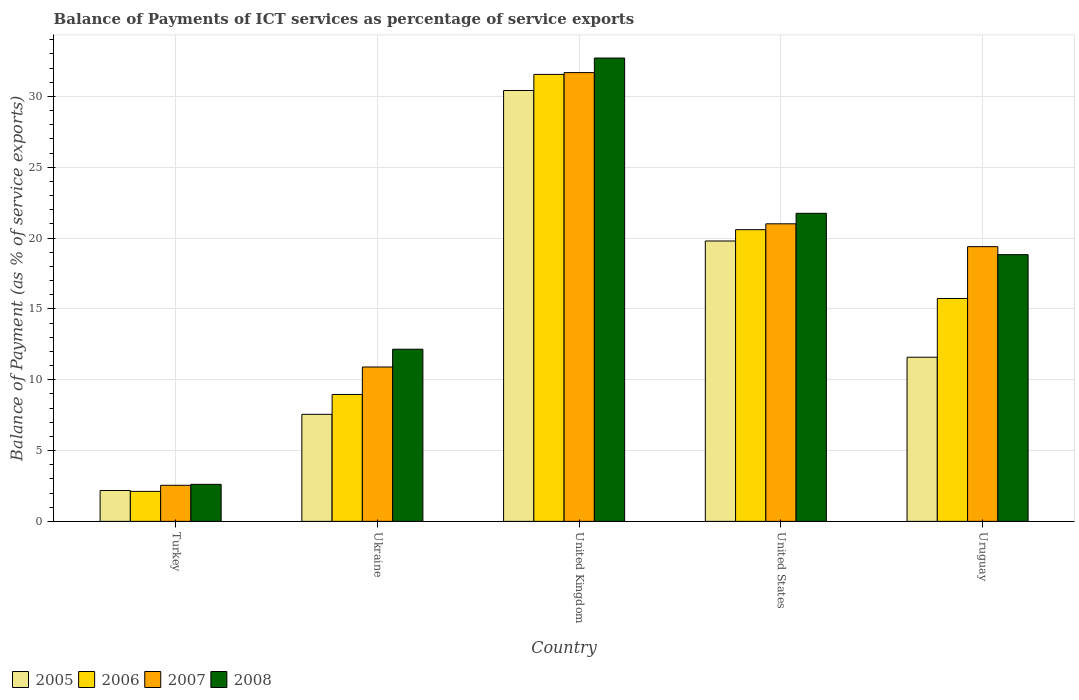How many groups of bars are there?
Offer a very short reply. 5. Are the number of bars on each tick of the X-axis equal?
Make the answer very short. Yes. How many bars are there on the 1st tick from the right?
Make the answer very short. 4. What is the balance of payments of ICT services in 2005 in Uruguay?
Offer a very short reply. 11.59. Across all countries, what is the maximum balance of payments of ICT services in 2006?
Offer a very short reply. 31.55. Across all countries, what is the minimum balance of payments of ICT services in 2007?
Your answer should be very brief. 2.55. In which country was the balance of payments of ICT services in 2005 minimum?
Offer a terse response. Turkey. What is the total balance of payments of ICT services in 2005 in the graph?
Ensure brevity in your answer.  71.52. What is the difference between the balance of payments of ICT services in 2006 in Turkey and that in Ukraine?
Keep it short and to the point. -6.84. What is the difference between the balance of payments of ICT services in 2006 in United Kingdom and the balance of payments of ICT services in 2007 in United States?
Ensure brevity in your answer.  10.55. What is the average balance of payments of ICT services in 2006 per country?
Your response must be concise. 15.79. What is the difference between the balance of payments of ICT services of/in 2006 and balance of payments of ICT services of/in 2008 in Turkey?
Offer a terse response. -0.5. What is the ratio of the balance of payments of ICT services in 2006 in United Kingdom to that in United States?
Your response must be concise. 1.53. What is the difference between the highest and the second highest balance of payments of ICT services in 2005?
Provide a succinct answer. -8.2. What is the difference between the highest and the lowest balance of payments of ICT services in 2008?
Provide a short and direct response. 30.09. Is it the case that in every country, the sum of the balance of payments of ICT services in 2007 and balance of payments of ICT services in 2008 is greater than the sum of balance of payments of ICT services in 2005 and balance of payments of ICT services in 2006?
Your answer should be compact. No. What does the 4th bar from the left in United Kingdom represents?
Provide a succinct answer. 2008. What does the 4th bar from the right in United Kingdom represents?
Offer a very short reply. 2005. Is it the case that in every country, the sum of the balance of payments of ICT services in 2007 and balance of payments of ICT services in 2006 is greater than the balance of payments of ICT services in 2008?
Give a very brief answer. Yes. How many bars are there?
Your answer should be compact. 20. Are all the bars in the graph horizontal?
Ensure brevity in your answer.  No. Does the graph contain any zero values?
Ensure brevity in your answer.  No. Does the graph contain grids?
Provide a short and direct response. Yes. How many legend labels are there?
Ensure brevity in your answer.  4. How are the legend labels stacked?
Ensure brevity in your answer.  Horizontal. What is the title of the graph?
Your response must be concise. Balance of Payments of ICT services as percentage of service exports. What is the label or title of the Y-axis?
Provide a succinct answer. Balance of Payment (as % of service exports). What is the Balance of Payment (as % of service exports) in 2005 in Turkey?
Your response must be concise. 2.18. What is the Balance of Payment (as % of service exports) of 2006 in Turkey?
Your response must be concise. 2.12. What is the Balance of Payment (as % of service exports) of 2007 in Turkey?
Make the answer very short. 2.55. What is the Balance of Payment (as % of service exports) in 2008 in Turkey?
Ensure brevity in your answer.  2.61. What is the Balance of Payment (as % of service exports) in 2005 in Ukraine?
Your response must be concise. 7.56. What is the Balance of Payment (as % of service exports) of 2006 in Ukraine?
Provide a short and direct response. 8.96. What is the Balance of Payment (as % of service exports) of 2007 in Ukraine?
Give a very brief answer. 10.9. What is the Balance of Payment (as % of service exports) of 2008 in Ukraine?
Make the answer very short. 12.15. What is the Balance of Payment (as % of service exports) of 2005 in United Kingdom?
Offer a very short reply. 30.41. What is the Balance of Payment (as % of service exports) in 2006 in United Kingdom?
Ensure brevity in your answer.  31.55. What is the Balance of Payment (as % of service exports) of 2007 in United Kingdom?
Your answer should be compact. 31.68. What is the Balance of Payment (as % of service exports) of 2008 in United Kingdom?
Ensure brevity in your answer.  32.7. What is the Balance of Payment (as % of service exports) of 2005 in United States?
Your answer should be compact. 19.79. What is the Balance of Payment (as % of service exports) in 2006 in United States?
Your answer should be very brief. 20.59. What is the Balance of Payment (as % of service exports) of 2007 in United States?
Ensure brevity in your answer.  21. What is the Balance of Payment (as % of service exports) in 2008 in United States?
Provide a succinct answer. 21.74. What is the Balance of Payment (as % of service exports) in 2005 in Uruguay?
Make the answer very short. 11.59. What is the Balance of Payment (as % of service exports) of 2006 in Uruguay?
Keep it short and to the point. 15.73. What is the Balance of Payment (as % of service exports) in 2007 in Uruguay?
Your response must be concise. 19.39. What is the Balance of Payment (as % of service exports) in 2008 in Uruguay?
Offer a terse response. 18.83. Across all countries, what is the maximum Balance of Payment (as % of service exports) of 2005?
Keep it short and to the point. 30.41. Across all countries, what is the maximum Balance of Payment (as % of service exports) of 2006?
Ensure brevity in your answer.  31.55. Across all countries, what is the maximum Balance of Payment (as % of service exports) in 2007?
Ensure brevity in your answer.  31.68. Across all countries, what is the maximum Balance of Payment (as % of service exports) of 2008?
Your response must be concise. 32.7. Across all countries, what is the minimum Balance of Payment (as % of service exports) in 2005?
Your answer should be compact. 2.18. Across all countries, what is the minimum Balance of Payment (as % of service exports) in 2006?
Offer a very short reply. 2.12. Across all countries, what is the minimum Balance of Payment (as % of service exports) in 2007?
Provide a short and direct response. 2.55. Across all countries, what is the minimum Balance of Payment (as % of service exports) in 2008?
Offer a terse response. 2.61. What is the total Balance of Payment (as % of service exports) of 2005 in the graph?
Provide a succinct answer. 71.52. What is the total Balance of Payment (as % of service exports) of 2006 in the graph?
Your answer should be very brief. 78.94. What is the total Balance of Payment (as % of service exports) in 2007 in the graph?
Your response must be concise. 85.51. What is the total Balance of Payment (as % of service exports) of 2008 in the graph?
Make the answer very short. 88.04. What is the difference between the Balance of Payment (as % of service exports) of 2005 in Turkey and that in Ukraine?
Make the answer very short. -5.38. What is the difference between the Balance of Payment (as % of service exports) of 2006 in Turkey and that in Ukraine?
Provide a short and direct response. -6.84. What is the difference between the Balance of Payment (as % of service exports) of 2007 in Turkey and that in Ukraine?
Your answer should be compact. -8.35. What is the difference between the Balance of Payment (as % of service exports) of 2008 in Turkey and that in Ukraine?
Give a very brief answer. -9.54. What is the difference between the Balance of Payment (as % of service exports) in 2005 in Turkey and that in United Kingdom?
Ensure brevity in your answer.  -28.23. What is the difference between the Balance of Payment (as % of service exports) in 2006 in Turkey and that in United Kingdom?
Give a very brief answer. -29.43. What is the difference between the Balance of Payment (as % of service exports) in 2007 in Turkey and that in United Kingdom?
Give a very brief answer. -29.13. What is the difference between the Balance of Payment (as % of service exports) in 2008 in Turkey and that in United Kingdom?
Provide a short and direct response. -30.09. What is the difference between the Balance of Payment (as % of service exports) of 2005 in Turkey and that in United States?
Your answer should be very brief. -17.61. What is the difference between the Balance of Payment (as % of service exports) in 2006 in Turkey and that in United States?
Your answer should be compact. -18.47. What is the difference between the Balance of Payment (as % of service exports) of 2007 in Turkey and that in United States?
Keep it short and to the point. -18.46. What is the difference between the Balance of Payment (as % of service exports) of 2008 in Turkey and that in United States?
Make the answer very short. -19.13. What is the difference between the Balance of Payment (as % of service exports) of 2005 in Turkey and that in Uruguay?
Offer a terse response. -9.41. What is the difference between the Balance of Payment (as % of service exports) of 2006 in Turkey and that in Uruguay?
Provide a short and direct response. -13.62. What is the difference between the Balance of Payment (as % of service exports) in 2007 in Turkey and that in Uruguay?
Your response must be concise. -16.84. What is the difference between the Balance of Payment (as % of service exports) in 2008 in Turkey and that in Uruguay?
Provide a succinct answer. -16.21. What is the difference between the Balance of Payment (as % of service exports) of 2005 in Ukraine and that in United Kingdom?
Your answer should be very brief. -22.86. What is the difference between the Balance of Payment (as % of service exports) in 2006 in Ukraine and that in United Kingdom?
Provide a short and direct response. -22.59. What is the difference between the Balance of Payment (as % of service exports) in 2007 in Ukraine and that in United Kingdom?
Make the answer very short. -20.78. What is the difference between the Balance of Payment (as % of service exports) in 2008 in Ukraine and that in United Kingdom?
Make the answer very short. -20.55. What is the difference between the Balance of Payment (as % of service exports) in 2005 in Ukraine and that in United States?
Give a very brief answer. -12.23. What is the difference between the Balance of Payment (as % of service exports) in 2006 in Ukraine and that in United States?
Provide a short and direct response. -11.63. What is the difference between the Balance of Payment (as % of service exports) of 2007 in Ukraine and that in United States?
Keep it short and to the point. -10.11. What is the difference between the Balance of Payment (as % of service exports) in 2008 in Ukraine and that in United States?
Keep it short and to the point. -9.59. What is the difference between the Balance of Payment (as % of service exports) in 2005 in Ukraine and that in Uruguay?
Ensure brevity in your answer.  -4.03. What is the difference between the Balance of Payment (as % of service exports) of 2006 in Ukraine and that in Uruguay?
Your answer should be compact. -6.77. What is the difference between the Balance of Payment (as % of service exports) in 2007 in Ukraine and that in Uruguay?
Your answer should be compact. -8.49. What is the difference between the Balance of Payment (as % of service exports) in 2008 in Ukraine and that in Uruguay?
Offer a very short reply. -6.68. What is the difference between the Balance of Payment (as % of service exports) of 2005 in United Kingdom and that in United States?
Offer a very short reply. 10.62. What is the difference between the Balance of Payment (as % of service exports) of 2006 in United Kingdom and that in United States?
Offer a terse response. 10.96. What is the difference between the Balance of Payment (as % of service exports) in 2007 in United Kingdom and that in United States?
Your response must be concise. 10.67. What is the difference between the Balance of Payment (as % of service exports) in 2008 in United Kingdom and that in United States?
Keep it short and to the point. 10.96. What is the difference between the Balance of Payment (as % of service exports) in 2005 in United Kingdom and that in Uruguay?
Your answer should be very brief. 18.83. What is the difference between the Balance of Payment (as % of service exports) of 2006 in United Kingdom and that in Uruguay?
Ensure brevity in your answer.  15.82. What is the difference between the Balance of Payment (as % of service exports) in 2007 in United Kingdom and that in Uruguay?
Offer a very short reply. 12.29. What is the difference between the Balance of Payment (as % of service exports) of 2008 in United Kingdom and that in Uruguay?
Your answer should be very brief. 13.88. What is the difference between the Balance of Payment (as % of service exports) of 2005 in United States and that in Uruguay?
Make the answer very short. 8.2. What is the difference between the Balance of Payment (as % of service exports) in 2006 in United States and that in Uruguay?
Your answer should be very brief. 4.86. What is the difference between the Balance of Payment (as % of service exports) in 2007 in United States and that in Uruguay?
Give a very brief answer. 1.61. What is the difference between the Balance of Payment (as % of service exports) of 2008 in United States and that in Uruguay?
Your answer should be compact. 2.92. What is the difference between the Balance of Payment (as % of service exports) in 2005 in Turkey and the Balance of Payment (as % of service exports) in 2006 in Ukraine?
Make the answer very short. -6.78. What is the difference between the Balance of Payment (as % of service exports) of 2005 in Turkey and the Balance of Payment (as % of service exports) of 2007 in Ukraine?
Provide a succinct answer. -8.72. What is the difference between the Balance of Payment (as % of service exports) in 2005 in Turkey and the Balance of Payment (as % of service exports) in 2008 in Ukraine?
Offer a terse response. -9.97. What is the difference between the Balance of Payment (as % of service exports) in 2006 in Turkey and the Balance of Payment (as % of service exports) in 2007 in Ukraine?
Ensure brevity in your answer.  -8.78. What is the difference between the Balance of Payment (as % of service exports) of 2006 in Turkey and the Balance of Payment (as % of service exports) of 2008 in Ukraine?
Offer a very short reply. -10.03. What is the difference between the Balance of Payment (as % of service exports) of 2007 in Turkey and the Balance of Payment (as % of service exports) of 2008 in Ukraine?
Offer a very short reply. -9.6. What is the difference between the Balance of Payment (as % of service exports) of 2005 in Turkey and the Balance of Payment (as % of service exports) of 2006 in United Kingdom?
Your answer should be very brief. -29.37. What is the difference between the Balance of Payment (as % of service exports) in 2005 in Turkey and the Balance of Payment (as % of service exports) in 2007 in United Kingdom?
Provide a succinct answer. -29.5. What is the difference between the Balance of Payment (as % of service exports) in 2005 in Turkey and the Balance of Payment (as % of service exports) in 2008 in United Kingdom?
Give a very brief answer. -30.52. What is the difference between the Balance of Payment (as % of service exports) in 2006 in Turkey and the Balance of Payment (as % of service exports) in 2007 in United Kingdom?
Ensure brevity in your answer.  -29.56. What is the difference between the Balance of Payment (as % of service exports) in 2006 in Turkey and the Balance of Payment (as % of service exports) in 2008 in United Kingdom?
Your answer should be compact. -30.59. What is the difference between the Balance of Payment (as % of service exports) in 2007 in Turkey and the Balance of Payment (as % of service exports) in 2008 in United Kingdom?
Your answer should be compact. -30.16. What is the difference between the Balance of Payment (as % of service exports) of 2005 in Turkey and the Balance of Payment (as % of service exports) of 2006 in United States?
Give a very brief answer. -18.41. What is the difference between the Balance of Payment (as % of service exports) of 2005 in Turkey and the Balance of Payment (as % of service exports) of 2007 in United States?
Offer a terse response. -18.82. What is the difference between the Balance of Payment (as % of service exports) of 2005 in Turkey and the Balance of Payment (as % of service exports) of 2008 in United States?
Keep it short and to the point. -19.57. What is the difference between the Balance of Payment (as % of service exports) in 2006 in Turkey and the Balance of Payment (as % of service exports) in 2007 in United States?
Make the answer very short. -18.89. What is the difference between the Balance of Payment (as % of service exports) of 2006 in Turkey and the Balance of Payment (as % of service exports) of 2008 in United States?
Offer a very short reply. -19.63. What is the difference between the Balance of Payment (as % of service exports) in 2007 in Turkey and the Balance of Payment (as % of service exports) in 2008 in United States?
Keep it short and to the point. -19.2. What is the difference between the Balance of Payment (as % of service exports) of 2005 in Turkey and the Balance of Payment (as % of service exports) of 2006 in Uruguay?
Your response must be concise. -13.55. What is the difference between the Balance of Payment (as % of service exports) in 2005 in Turkey and the Balance of Payment (as % of service exports) in 2007 in Uruguay?
Offer a terse response. -17.21. What is the difference between the Balance of Payment (as % of service exports) of 2005 in Turkey and the Balance of Payment (as % of service exports) of 2008 in Uruguay?
Provide a short and direct response. -16.65. What is the difference between the Balance of Payment (as % of service exports) of 2006 in Turkey and the Balance of Payment (as % of service exports) of 2007 in Uruguay?
Ensure brevity in your answer.  -17.27. What is the difference between the Balance of Payment (as % of service exports) in 2006 in Turkey and the Balance of Payment (as % of service exports) in 2008 in Uruguay?
Ensure brevity in your answer.  -16.71. What is the difference between the Balance of Payment (as % of service exports) of 2007 in Turkey and the Balance of Payment (as % of service exports) of 2008 in Uruguay?
Your answer should be very brief. -16.28. What is the difference between the Balance of Payment (as % of service exports) in 2005 in Ukraine and the Balance of Payment (as % of service exports) in 2006 in United Kingdom?
Your response must be concise. -23.99. What is the difference between the Balance of Payment (as % of service exports) of 2005 in Ukraine and the Balance of Payment (as % of service exports) of 2007 in United Kingdom?
Give a very brief answer. -24.12. What is the difference between the Balance of Payment (as % of service exports) of 2005 in Ukraine and the Balance of Payment (as % of service exports) of 2008 in United Kingdom?
Your response must be concise. -25.15. What is the difference between the Balance of Payment (as % of service exports) in 2006 in Ukraine and the Balance of Payment (as % of service exports) in 2007 in United Kingdom?
Provide a short and direct response. -22.72. What is the difference between the Balance of Payment (as % of service exports) in 2006 in Ukraine and the Balance of Payment (as % of service exports) in 2008 in United Kingdom?
Provide a short and direct response. -23.75. What is the difference between the Balance of Payment (as % of service exports) of 2007 in Ukraine and the Balance of Payment (as % of service exports) of 2008 in United Kingdom?
Your answer should be compact. -21.81. What is the difference between the Balance of Payment (as % of service exports) of 2005 in Ukraine and the Balance of Payment (as % of service exports) of 2006 in United States?
Your answer should be compact. -13.03. What is the difference between the Balance of Payment (as % of service exports) in 2005 in Ukraine and the Balance of Payment (as % of service exports) in 2007 in United States?
Your answer should be compact. -13.45. What is the difference between the Balance of Payment (as % of service exports) of 2005 in Ukraine and the Balance of Payment (as % of service exports) of 2008 in United States?
Your response must be concise. -14.19. What is the difference between the Balance of Payment (as % of service exports) of 2006 in Ukraine and the Balance of Payment (as % of service exports) of 2007 in United States?
Your answer should be compact. -12.05. What is the difference between the Balance of Payment (as % of service exports) in 2006 in Ukraine and the Balance of Payment (as % of service exports) in 2008 in United States?
Your answer should be compact. -12.79. What is the difference between the Balance of Payment (as % of service exports) in 2007 in Ukraine and the Balance of Payment (as % of service exports) in 2008 in United States?
Provide a succinct answer. -10.85. What is the difference between the Balance of Payment (as % of service exports) in 2005 in Ukraine and the Balance of Payment (as % of service exports) in 2006 in Uruguay?
Give a very brief answer. -8.18. What is the difference between the Balance of Payment (as % of service exports) in 2005 in Ukraine and the Balance of Payment (as % of service exports) in 2007 in Uruguay?
Ensure brevity in your answer.  -11.83. What is the difference between the Balance of Payment (as % of service exports) in 2005 in Ukraine and the Balance of Payment (as % of service exports) in 2008 in Uruguay?
Provide a short and direct response. -11.27. What is the difference between the Balance of Payment (as % of service exports) of 2006 in Ukraine and the Balance of Payment (as % of service exports) of 2007 in Uruguay?
Offer a terse response. -10.43. What is the difference between the Balance of Payment (as % of service exports) of 2006 in Ukraine and the Balance of Payment (as % of service exports) of 2008 in Uruguay?
Make the answer very short. -9.87. What is the difference between the Balance of Payment (as % of service exports) in 2007 in Ukraine and the Balance of Payment (as % of service exports) in 2008 in Uruguay?
Your answer should be very brief. -7.93. What is the difference between the Balance of Payment (as % of service exports) of 2005 in United Kingdom and the Balance of Payment (as % of service exports) of 2006 in United States?
Provide a short and direct response. 9.82. What is the difference between the Balance of Payment (as % of service exports) in 2005 in United Kingdom and the Balance of Payment (as % of service exports) in 2007 in United States?
Your answer should be very brief. 9.41. What is the difference between the Balance of Payment (as % of service exports) in 2005 in United Kingdom and the Balance of Payment (as % of service exports) in 2008 in United States?
Your answer should be very brief. 8.67. What is the difference between the Balance of Payment (as % of service exports) in 2006 in United Kingdom and the Balance of Payment (as % of service exports) in 2007 in United States?
Give a very brief answer. 10.55. What is the difference between the Balance of Payment (as % of service exports) in 2006 in United Kingdom and the Balance of Payment (as % of service exports) in 2008 in United States?
Your answer should be compact. 9.8. What is the difference between the Balance of Payment (as % of service exports) of 2007 in United Kingdom and the Balance of Payment (as % of service exports) of 2008 in United States?
Offer a very short reply. 9.93. What is the difference between the Balance of Payment (as % of service exports) in 2005 in United Kingdom and the Balance of Payment (as % of service exports) in 2006 in Uruguay?
Make the answer very short. 14.68. What is the difference between the Balance of Payment (as % of service exports) of 2005 in United Kingdom and the Balance of Payment (as % of service exports) of 2007 in Uruguay?
Ensure brevity in your answer.  11.02. What is the difference between the Balance of Payment (as % of service exports) of 2005 in United Kingdom and the Balance of Payment (as % of service exports) of 2008 in Uruguay?
Your answer should be very brief. 11.59. What is the difference between the Balance of Payment (as % of service exports) in 2006 in United Kingdom and the Balance of Payment (as % of service exports) in 2007 in Uruguay?
Your response must be concise. 12.16. What is the difference between the Balance of Payment (as % of service exports) in 2006 in United Kingdom and the Balance of Payment (as % of service exports) in 2008 in Uruguay?
Provide a succinct answer. 12.72. What is the difference between the Balance of Payment (as % of service exports) in 2007 in United Kingdom and the Balance of Payment (as % of service exports) in 2008 in Uruguay?
Give a very brief answer. 12.85. What is the difference between the Balance of Payment (as % of service exports) in 2005 in United States and the Balance of Payment (as % of service exports) in 2006 in Uruguay?
Make the answer very short. 4.06. What is the difference between the Balance of Payment (as % of service exports) of 2005 in United States and the Balance of Payment (as % of service exports) of 2007 in Uruguay?
Your answer should be very brief. 0.4. What is the difference between the Balance of Payment (as % of service exports) in 2005 in United States and the Balance of Payment (as % of service exports) in 2008 in Uruguay?
Offer a terse response. 0.96. What is the difference between the Balance of Payment (as % of service exports) in 2006 in United States and the Balance of Payment (as % of service exports) in 2007 in Uruguay?
Give a very brief answer. 1.2. What is the difference between the Balance of Payment (as % of service exports) in 2006 in United States and the Balance of Payment (as % of service exports) in 2008 in Uruguay?
Ensure brevity in your answer.  1.76. What is the difference between the Balance of Payment (as % of service exports) in 2007 in United States and the Balance of Payment (as % of service exports) in 2008 in Uruguay?
Make the answer very short. 2.18. What is the average Balance of Payment (as % of service exports) of 2005 per country?
Give a very brief answer. 14.3. What is the average Balance of Payment (as % of service exports) in 2006 per country?
Your answer should be compact. 15.79. What is the average Balance of Payment (as % of service exports) of 2007 per country?
Keep it short and to the point. 17.1. What is the average Balance of Payment (as % of service exports) in 2008 per country?
Offer a terse response. 17.61. What is the difference between the Balance of Payment (as % of service exports) in 2005 and Balance of Payment (as % of service exports) in 2006 in Turkey?
Your response must be concise. 0.06. What is the difference between the Balance of Payment (as % of service exports) in 2005 and Balance of Payment (as % of service exports) in 2007 in Turkey?
Your answer should be compact. -0.37. What is the difference between the Balance of Payment (as % of service exports) of 2005 and Balance of Payment (as % of service exports) of 2008 in Turkey?
Give a very brief answer. -0.44. What is the difference between the Balance of Payment (as % of service exports) of 2006 and Balance of Payment (as % of service exports) of 2007 in Turkey?
Offer a terse response. -0.43. What is the difference between the Balance of Payment (as % of service exports) of 2006 and Balance of Payment (as % of service exports) of 2008 in Turkey?
Provide a succinct answer. -0.5. What is the difference between the Balance of Payment (as % of service exports) in 2007 and Balance of Payment (as % of service exports) in 2008 in Turkey?
Provide a short and direct response. -0.07. What is the difference between the Balance of Payment (as % of service exports) of 2005 and Balance of Payment (as % of service exports) of 2006 in Ukraine?
Keep it short and to the point. -1.4. What is the difference between the Balance of Payment (as % of service exports) of 2005 and Balance of Payment (as % of service exports) of 2007 in Ukraine?
Ensure brevity in your answer.  -3.34. What is the difference between the Balance of Payment (as % of service exports) in 2005 and Balance of Payment (as % of service exports) in 2008 in Ukraine?
Your answer should be compact. -4.59. What is the difference between the Balance of Payment (as % of service exports) in 2006 and Balance of Payment (as % of service exports) in 2007 in Ukraine?
Make the answer very short. -1.94. What is the difference between the Balance of Payment (as % of service exports) in 2006 and Balance of Payment (as % of service exports) in 2008 in Ukraine?
Your answer should be compact. -3.19. What is the difference between the Balance of Payment (as % of service exports) of 2007 and Balance of Payment (as % of service exports) of 2008 in Ukraine?
Ensure brevity in your answer.  -1.25. What is the difference between the Balance of Payment (as % of service exports) in 2005 and Balance of Payment (as % of service exports) in 2006 in United Kingdom?
Provide a succinct answer. -1.14. What is the difference between the Balance of Payment (as % of service exports) of 2005 and Balance of Payment (as % of service exports) of 2007 in United Kingdom?
Make the answer very short. -1.26. What is the difference between the Balance of Payment (as % of service exports) of 2005 and Balance of Payment (as % of service exports) of 2008 in United Kingdom?
Your answer should be very brief. -2.29. What is the difference between the Balance of Payment (as % of service exports) in 2006 and Balance of Payment (as % of service exports) in 2007 in United Kingdom?
Ensure brevity in your answer.  -0.13. What is the difference between the Balance of Payment (as % of service exports) in 2006 and Balance of Payment (as % of service exports) in 2008 in United Kingdom?
Offer a terse response. -1.16. What is the difference between the Balance of Payment (as % of service exports) in 2007 and Balance of Payment (as % of service exports) in 2008 in United Kingdom?
Ensure brevity in your answer.  -1.03. What is the difference between the Balance of Payment (as % of service exports) in 2005 and Balance of Payment (as % of service exports) in 2006 in United States?
Provide a short and direct response. -0.8. What is the difference between the Balance of Payment (as % of service exports) of 2005 and Balance of Payment (as % of service exports) of 2007 in United States?
Your response must be concise. -1.21. What is the difference between the Balance of Payment (as % of service exports) of 2005 and Balance of Payment (as % of service exports) of 2008 in United States?
Offer a very short reply. -1.95. What is the difference between the Balance of Payment (as % of service exports) of 2006 and Balance of Payment (as % of service exports) of 2007 in United States?
Provide a succinct answer. -0.41. What is the difference between the Balance of Payment (as % of service exports) of 2006 and Balance of Payment (as % of service exports) of 2008 in United States?
Your answer should be very brief. -1.15. What is the difference between the Balance of Payment (as % of service exports) of 2007 and Balance of Payment (as % of service exports) of 2008 in United States?
Your answer should be very brief. -0.74. What is the difference between the Balance of Payment (as % of service exports) in 2005 and Balance of Payment (as % of service exports) in 2006 in Uruguay?
Your answer should be very brief. -4.15. What is the difference between the Balance of Payment (as % of service exports) in 2005 and Balance of Payment (as % of service exports) in 2007 in Uruguay?
Your answer should be compact. -7.8. What is the difference between the Balance of Payment (as % of service exports) of 2005 and Balance of Payment (as % of service exports) of 2008 in Uruguay?
Your answer should be very brief. -7.24. What is the difference between the Balance of Payment (as % of service exports) in 2006 and Balance of Payment (as % of service exports) in 2007 in Uruguay?
Give a very brief answer. -3.66. What is the difference between the Balance of Payment (as % of service exports) in 2006 and Balance of Payment (as % of service exports) in 2008 in Uruguay?
Your response must be concise. -3.09. What is the difference between the Balance of Payment (as % of service exports) in 2007 and Balance of Payment (as % of service exports) in 2008 in Uruguay?
Offer a terse response. 0.56. What is the ratio of the Balance of Payment (as % of service exports) in 2005 in Turkey to that in Ukraine?
Your answer should be compact. 0.29. What is the ratio of the Balance of Payment (as % of service exports) in 2006 in Turkey to that in Ukraine?
Offer a very short reply. 0.24. What is the ratio of the Balance of Payment (as % of service exports) in 2007 in Turkey to that in Ukraine?
Provide a short and direct response. 0.23. What is the ratio of the Balance of Payment (as % of service exports) of 2008 in Turkey to that in Ukraine?
Ensure brevity in your answer.  0.22. What is the ratio of the Balance of Payment (as % of service exports) of 2005 in Turkey to that in United Kingdom?
Offer a very short reply. 0.07. What is the ratio of the Balance of Payment (as % of service exports) in 2006 in Turkey to that in United Kingdom?
Offer a very short reply. 0.07. What is the ratio of the Balance of Payment (as % of service exports) of 2007 in Turkey to that in United Kingdom?
Give a very brief answer. 0.08. What is the ratio of the Balance of Payment (as % of service exports) in 2008 in Turkey to that in United Kingdom?
Keep it short and to the point. 0.08. What is the ratio of the Balance of Payment (as % of service exports) in 2005 in Turkey to that in United States?
Provide a short and direct response. 0.11. What is the ratio of the Balance of Payment (as % of service exports) of 2006 in Turkey to that in United States?
Your answer should be compact. 0.1. What is the ratio of the Balance of Payment (as % of service exports) of 2007 in Turkey to that in United States?
Make the answer very short. 0.12. What is the ratio of the Balance of Payment (as % of service exports) of 2008 in Turkey to that in United States?
Your answer should be very brief. 0.12. What is the ratio of the Balance of Payment (as % of service exports) of 2005 in Turkey to that in Uruguay?
Make the answer very short. 0.19. What is the ratio of the Balance of Payment (as % of service exports) of 2006 in Turkey to that in Uruguay?
Ensure brevity in your answer.  0.13. What is the ratio of the Balance of Payment (as % of service exports) in 2007 in Turkey to that in Uruguay?
Your response must be concise. 0.13. What is the ratio of the Balance of Payment (as % of service exports) in 2008 in Turkey to that in Uruguay?
Give a very brief answer. 0.14. What is the ratio of the Balance of Payment (as % of service exports) in 2005 in Ukraine to that in United Kingdom?
Provide a short and direct response. 0.25. What is the ratio of the Balance of Payment (as % of service exports) in 2006 in Ukraine to that in United Kingdom?
Make the answer very short. 0.28. What is the ratio of the Balance of Payment (as % of service exports) in 2007 in Ukraine to that in United Kingdom?
Your response must be concise. 0.34. What is the ratio of the Balance of Payment (as % of service exports) of 2008 in Ukraine to that in United Kingdom?
Your answer should be compact. 0.37. What is the ratio of the Balance of Payment (as % of service exports) of 2005 in Ukraine to that in United States?
Ensure brevity in your answer.  0.38. What is the ratio of the Balance of Payment (as % of service exports) of 2006 in Ukraine to that in United States?
Your answer should be compact. 0.43. What is the ratio of the Balance of Payment (as % of service exports) in 2007 in Ukraine to that in United States?
Offer a very short reply. 0.52. What is the ratio of the Balance of Payment (as % of service exports) in 2008 in Ukraine to that in United States?
Make the answer very short. 0.56. What is the ratio of the Balance of Payment (as % of service exports) in 2005 in Ukraine to that in Uruguay?
Offer a very short reply. 0.65. What is the ratio of the Balance of Payment (as % of service exports) in 2006 in Ukraine to that in Uruguay?
Offer a terse response. 0.57. What is the ratio of the Balance of Payment (as % of service exports) of 2007 in Ukraine to that in Uruguay?
Your response must be concise. 0.56. What is the ratio of the Balance of Payment (as % of service exports) in 2008 in Ukraine to that in Uruguay?
Your response must be concise. 0.65. What is the ratio of the Balance of Payment (as % of service exports) of 2005 in United Kingdom to that in United States?
Provide a succinct answer. 1.54. What is the ratio of the Balance of Payment (as % of service exports) in 2006 in United Kingdom to that in United States?
Give a very brief answer. 1.53. What is the ratio of the Balance of Payment (as % of service exports) of 2007 in United Kingdom to that in United States?
Provide a succinct answer. 1.51. What is the ratio of the Balance of Payment (as % of service exports) in 2008 in United Kingdom to that in United States?
Keep it short and to the point. 1.5. What is the ratio of the Balance of Payment (as % of service exports) of 2005 in United Kingdom to that in Uruguay?
Provide a succinct answer. 2.62. What is the ratio of the Balance of Payment (as % of service exports) in 2006 in United Kingdom to that in Uruguay?
Provide a short and direct response. 2.01. What is the ratio of the Balance of Payment (as % of service exports) in 2007 in United Kingdom to that in Uruguay?
Ensure brevity in your answer.  1.63. What is the ratio of the Balance of Payment (as % of service exports) in 2008 in United Kingdom to that in Uruguay?
Offer a very short reply. 1.74. What is the ratio of the Balance of Payment (as % of service exports) of 2005 in United States to that in Uruguay?
Ensure brevity in your answer.  1.71. What is the ratio of the Balance of Payment (as % of service exports) in 2006 in United States to that in Uruguay?
Ensure brevity in your answer.  1.31. What is the ratio of the Balance of Payment (as % of service exports) of 2007 in United States to that in Uruguay?
Keep it short and to the point. 1.08. What is the ratio of the Balance of Payment (as % of service exports) in 2008 in United States to that in Uruguay?
Your response must be concise. 1.16. What is the difference between the highest and the second highest Balance of Payment (as % of service exports) in 2005?
Your response must be concise. 10.62. What is the difference between the highest and the second highest Balance of Payment (as % of service exports) in 2006?
Your answer should be very brief. 10.96. What is the difference between the highest and the second highest Balance of Payment (as % of service exports) in 2007?
Offer a very short reply. 10.67. What is the difference between the highest and the second highest Balance of Payment (as % of service exports) in 2008?
Your response must be concise. 10.96. What is the difference between the highest and the lowest Balance of Payment (as % of service exports) in 2005?
Your answer should be very brief. 28.23. What is the difference between the highest and the lowest Balance of Payment (as % of service exports) of 2006?
Provide a succinct answer. 29.43. What is the difference between the highest and the lowest Balance of Payment (as % of service exports) in 2007?
Provide a succinct answer. 29.13. What is the difference between the highest and the lowest Balance of Payment (as % of service exports) of 2008?
Keep it short and to the point. 30.09. 